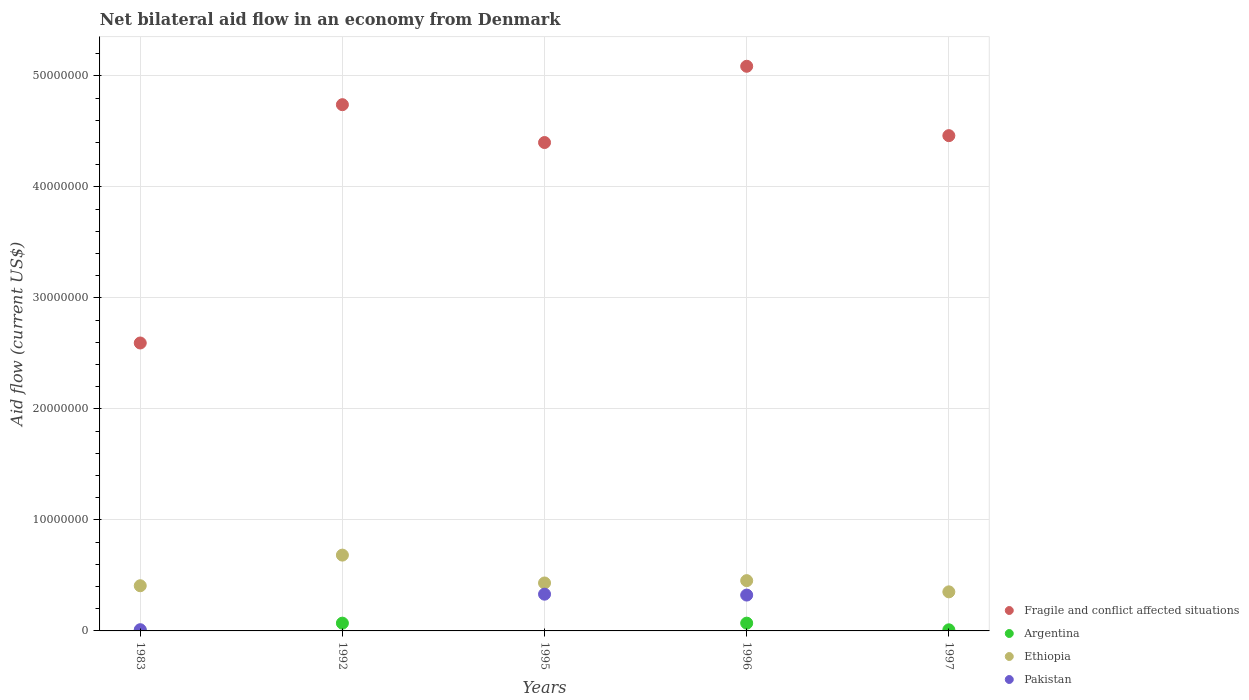How many different coloured dotlines are there?
Keep it short and to the point. 4. What is the net bilateral aid flow in Fragile and conflict affected situations in 1995?
Ensure brevity in your answer.  4.40e+07. Across all years, what is the maximum net bilateral aid flow in Ethiopia?
Ensure brevity in your answer.  6.83e+06. Across all years, what is the minimum net bilateral aid flow in Pakistan?
Your answer should be very brief. 0. What is the total net bilateral aid flow in Pakistan in the graph?
Offer a terse response. 6.65e+06. What is the difference between the net bilateral aid flow in Fragile and conflict affected situations in 1992 and the net bilateral aid flow in Pakistan in 1996?
Your answer should be compact. 4.42e+07. What is the average net bilateral aid flow in Fragile and conflict affected situations per year?
Make the answer very short. 4.26e+07. In the year 1996, what is the difference between the net bilateral aid flow in Fragile and conflict affected situations and net bilateral aid flow in Argentina?
Make the answer very short. 5.02e+07. What is the ratio of the net bilateral aid flow in Argentina in 1983 to that in 1996?
Offer a terse response. 0.01. What is the difference between the highest and the lowest net bilateral aid flow in Fragile and conflict affected situations?
Your answer should be compact. 2.49e+07. In how many years, is the net bilateral aid flow in Ethiopia greater than the average net bilateral aid flow in Ethiopia taken over all years?
Ensure brevity in your answer.  1. Is the sum of the net bilateral aid flow in Fragile and conflict affected situations in 1992 and 1995 greater than the maximum net bilateral aid flow in Argentina across all years?
Your answer should be compact. Yes. Is it the case that in every year, the sum of the net bilateral aid flow in Pakistan and net bilateral aid flow in Ethiopia  is greater than the sum of net bilateral aid flow in Argentina and net bilateral aid flow in Fragile and conflict affected situations?
Your response must be concise. Yes. Is it the case that in every year, the sum of the net bilateral aid flow in Fragile and conflict affected situations and net bilateral aid flow in Pakistan  is greater than the net bilateral aid flow in Ethiopia?
Make the answer very short. Yes. Does the net bilateral aid flow in Fragile and conflict affected situations monotonically increase over the years?
Your answer should be compact. No. Is the net bilateral aid flow in Ethiopia strictly less than the net bilateral aid flow in Fragile and conflict affected situations over the years?
Offer a terse response. Yes. How many dotlines are there?
Provide a succinct answer. 4. How many years are there in the graph?
Keep it short and to the point. 5. Are the values on the major ticks of Y-axis written in scientific E-notation?
Keep it short and to the point. No. Does the graph contain grids?
Your answer should be very brief. Yes. Where does the legend appear in the graph?
Provide a succinct answer. Bottom right. What is the title of the graph?
Give a very brief answer. Net bilateral aid flow in an economy from Denmark. What is the label or title of the Y-axis?
Your response must be concise. Aid flow (current US$). What is the Aid flow (current US$) of Fragile and conflict affected situations in 1983?
Give a very brief answer. 2.59e+07. What is the Aid flow (current US$) in Argentina in 1983?
Offer a terse response. 10000. What is the Aid flow (current US$) in Ethiopia in 1983?
Provide a succinct answer. 4.07e+06. What is the Aid flow (current US$) of Pakistan in 1983?
Give a very brief answer. 1.10e+05. What is the Aid flow (current US$) in Fragile and conflict affected situations in 1992?
Ensure brevity in your answer.  4.74e+07. What is the Aid flow (current US$) in Ethiopia in 1992?
Your answer should be compact. 6.83e+06. What is the Aid flow (current US$) in Fragile and conflict affected situations in 1995?
Your response must be concise. 4.40e+07. What is the Aid flow (current US$) in Argentina in 1995?
Provide a short and direct response. 0. What is the Aid flow (current US$) in Ethiopia in 1995?
Give a very brief answer. 4.32e+06. What is the Aid flow (current US$) in Pakistan in 1995?
Your response must be concise. 3.31e+06. What is the Aid flow (current US$) of Fragile and conflict affected situations in 1996?
Give a very brief answer. 5.09e+07. What is the Aid flow (current US$) in Ethiopia in 1996?
Ensure brevity in your answer.  4.53e+06. What is the Aid flow (current US$) of Pakistan in 1996?
Offer a terse response. 3.23e+06. What is the Aid flow (current US$) in Fragile and conflict affected situations in 1997?
Your answer should be compact. 4.46e+07. What is the Aid flow (current US$) in Ethiopia in 1997?
Give a very brief answer. 3.52e+06. Across all years, what is the maximum Aid flow (current US$) of Fragile and conflict affected situations?
Your answer should be very brief. 5.09e+07. Across all years, what is the maximum Aid flow (current US$) in Ethiopia?
Provide a short and direct response. 6.83e+06. Across all years, what is the maximum Aid flow (current US$) in Pakistan?
Your answer should be very brief. 3.31e+06. Across all years, what is the minimum Aid flow (current US$) in Fragile and conflict affected situations?
Make the answer very short. 2.59e+07. Across all years, what is the minimum Aid flow (current US$) of Ethiopia?
Keep it short and to the point. 3.52e+06. What is the total Aid flow (current US$) in Fragile and conflict affected situations in the graph?
Keep it short and to the point. 2.13e+08. What is the total Aid flow (current US$) in Argentina in the graph?
Keep it short and to the point. 1.51e+06. What is the total Aid flow (current US$) in Ethiopia in the graph?
Provide a short and direct response. 2.33e+07. What is the total Aid flow (current US$) of Pakistan in the graph?
Your response must be concise. 6.65e+06. What is the difference between the Aid flow (current US$) in Fragile and conflict affected situations in 1983 and that in 1992?
Make the answer very short. -2.15e+07. What is the difference between the Aid flow (current US$) in Argentina in 1983 and that in 1992?
Keep it short and to the point. -6.90e+05. What is the difference between the Aid flow (current US$) of Ethiopia in 1983 and that in 1992?
Your response must be concise. -2.76e+06. What is the difference between the Aid flow (current US$) in Fragile and conflict affected situations in 1983 and that in 1995?
Provide a short and direct response. -1.81e+07. What is the difference between the Aid flow (current US$) in Ethiopia in 1983 and that in 1995?
Provide a short and direct response. -2.50e+05. What is the difference between the Aid flow (current US$) of Pakistan in 1983 and that in 1995?
Give a very brief answer. -3.20e+06. What is the difference between the Aid flow (current US$) of Fragile and conflict affected situations in 1983 and that in 1996?
Offer a very short reply. -2.49e+07. What is the difference between the Aid flow (current US$) of Argentina in 1983 and that in 1996?
Make the answer very short. -6.90e+05. What is the difference between the Aid flow (current US$) of Ethiopia in 1983 and that in 1996?
Your answer should be very brief. -4.60e+05. What is the difference between the Aid flow (current US$) of Pakistan in 1983 and that in 1996?
Your response must be concise. -3.12e+06. What is the difference between the Aid flow (current US$) of Fragile and conflict affected situations in 1983 and that in 1997?
Your answer should be very brief. -1.87e+07. What is the difference between the Aid flow (current US$) of Argentina in 1983 and that in 1997?
Make the answer very short. -9.00e+04. What is the difference between the Aid flow (current US$) of Ethiopia in 1983 and that in 1997?
Make the answer very short. 5.50e+05. What is the difference between the Aid flow (current US$) of Fragile and conflict affected situations in 1992 and that in 1995?
Your response must be concise. 3.41e+06. What is the difference between the Aid flow (current US$) of Ethiopia in 1992 and that in 1995?
Your answer should be very brief. 2.51e+06. What is the difference between the Aid flow (current US$) of Fragile and conflict affected situations in 1992 and that in 1996?
Keep it short and to the point. -3.46e+06. What is the difference between the Aid flow (current US$) in Ethiopia in 1992 and that in 1996?
Keep it short and to the point. 2.30e+06. What is the difference between the Aid flow (current US$) of Fragile and conflict affected situations in 1992 and that in 1997?
Provide a short and direct response. 2.79e+06. What is the difference between the Aid flow (current US$) in Argentina in 1992 and that in 1997?
Provide a short and direct response. 6.00e+05. What is the difference between the Aid flow (current US$) in Ethiopia in 1992 and that in 1997?
Make the answer very short. 3.31e+06. What is the difference between the Aid flow (current US$) in Fragile and conflict affected situations in 1995 and that in 1996?
Offer a terse response. -6.87e+06. What is the difference between the Aid flow (current US$) in Pakistan in 1995 and that in 1996?
Your response must be concise. 8.00e+04. What is the difference between the Aid flow (current US$) in Fragile and conflict affected situations in 1995 and that in 1997?
Ensure brevity in your answer.  -6.20e+05. What is the difference between the Aid flow (current US$) in Fragile and conflict affected situations in 1996 and that in 1997?
Keep it short and to the point. 6.25e+06. What is the difference between the Aid flow (current US$) in Argentina in 1996 and that in 1997?
Your response must be concise. 6.00e+05. What is the difference between the Aid flow (current US$) of Ethiopia in 1996 and that in 1997?
Ensure brevity in your answer.  1.01e+06. What is the difference between the Aid flow (current US$) of Fragile and conflict affected situations in 1983 and the Aid flow (current US$) of Argentina in 1992?
Offer a very short reply. 2.52e+07. What is the difference between the Aid flow (current US$) in Fragile and conflict affected situations in 1983 and the Aid flow (current US$) in Ethiopia in 1992?
Keep it short and to the point. 1.91e+07. What is the difference between the Aid flow (current US$) in Argentina in 1983 and the Aid flow (current US$) in Ethiopia in 1992?
Your response must be concise. -6.82e+06. What is the difference between the Aid flow (current US$) in Fragile and conflict affected situations in 1983 and the Aid flow (current US$) in Ethiopia in 1995?
Ensure brevity in your answer.  2.16e+07. What is the difference between the Aid flow (current US$) of Fragile and conflict affected situations in 1983 and the Aid flow (current US$) of Pakistan in 1995?
Your answer should be compact. 2.26e+07. What is the difference between the Aid flow (current US$) in Argentina in 1983 and the Aid flow (current US$) in Ethiopia in 1995?
Your answer should be very brief. -4.31e+06. What is the difference between the Aid flow (current US$) in Argentina in 1983 and the Aid flow (current US$) in Pakistan in 1995?
Provide a short and direct response. -3.30e+06. What is the difference between the Aid flow (current US$) in Ethiopia in 1983 and the Aid flow (current US$) in Pakistan in 1995?
Provide a succinct answer. 7.60e+05. What is the difference between the Aid flow (current US$) in Fragile and conflict affected situations in 1983 and the Aid flow (current US$) in Argentina in 1996?
Offer a very short reply. 2.52e+07. What is the difference between the Aid flow (current US$) in Fragile and conflict affected situations in 1983 and the Aid flow (current US$) in Ethiopia in 1996?
Your response must be concise. 2.14e+07. What is the difference between the Aid flow (current US$) of Fragile and conflict affected situations in 1983 and the Aid flow (current US$) of Pakistan in 1996?
Provide a short and direct response. 2.27e+07. What is the difference between the Aid flow (current US$) in Argentina in 1983 and the Aid flow (current US$) in Ethiopia in 1996?
Keep it short and to the point. -4.52e+06. What is the difference between the Aid flow (current US$) of Argentina in 1983 and the Aid flow (current US$) of Pakistan in 1996?
Give a very brief answer. -3.22e+06. What is the difference between the Aid flow (current US$) in Ethiopia in 1983 and the Aid flow (current US$) in Pakistan in 1996?
Provide a succinct answer. 8.40e+05. What is the difference between the Aid flow (current US$) of Fragile and conflict affected situations in 1983 and the Aid flow (current US$) of Argentina in 1997?
Keep it short and to the point. 2.58e+07. What is the difference between the Aid flow (current US$) in Fragile and conflict affected situations in 1983 and the Aid flow (current US$) in Ethiopia in 1997?
Provide a short and direct response. 2.24e+07. What is the difference between the Aid flow (current US$) of Argentina in 1983 and the Aid flow (current US$) of Ethiopia in 1997?
Ensure brevity in your answer.  -3.51e+06. What is the difference between the Aid flow (current US$) of Fragile and conflict affected situations in 1992 and the Aid flow (current US$) of Ethiopia in 1995?
Offer a terse response. 4.31e+07. What is the difference between the Aid flow (current US$) in Fragile and conflict affected situations in 1992 and the Aid flow (current US$) in Pakistan in 1995?
Keep it short and to the point. 4.41e+07. What is the difference between the Aid flow (current US$) of Argentina in 1992 and the Aid flow (current US$) of Ethiopia in 1995?
Your answer should be very brief. -3.62e+06. What is the difference between the Aid flow (current US$) of Argentina in 1992 and the Aid flow (current US$) of Pakistan in 1995?
Keep it short and to the point. -2.61e+06. What is the difference between the Aid flow (current US$) in Ethiopia in 1992 and the Aid flow (current US$) in Pakistan in 1995?
Your answer should be very brief. 3.52e+06. What is the difference between the Aid flow (current US$) in Fragile and conflict affected situations in 1992 and the Aid flow (current US$) in Argentina in 1996?
Offer a very short reply. 4.67e+07. What is the difference between the Aid flow (current US$) in Fragile and conflict affected situations in 1992 and the Aid flow (current US$) in Ethiopia in 1996?
Provide a succinct answer. 4.29e+07. What is the difference between the Aid flow (current US$) in Fragile and conflict affected situations in 1992 and the Aid flow (current US$) in Pakistan in 1996?
Ensure brevity in your answer.  4.42e+07. What is the difference between the Aid flow (current US$) of Argentina in 1992 and the Aid flow (current US$) of Ethiopia in 1996?
Your answer should be compact. -3.83e+06. What is the difference between the Aid flow (current US$) in Argentina in 1992 and the Aid flow (current US$) in Pakistan in 1996?
Make the answer very short. -2.53e+06. What is the difference between the Aid flow (current US$) in Ethiopia in 1992 and the Aid flow (current US$) in Pakistan in 1996?
Ensure brevity in your answer.  3.60e+06. What is the difference between the Aid flow (current US$) in Fragile and conflict affected situations in 1992 and the Aid flow (current US$) in Argentina in 1997?
Ensure brevity in your answer.  4.73e+07. What is the difference between the Aid flow (current US$) of Fragile and conflict affected situations in 1992 and the Aid flow (current US$) of Ethiopia in 1997?
Give a very brief answer. 4.39e+07. What is the difference between the Aid flow (current US$) in Argentina in 1992 and the Aid flow (current US$) in Ethiopia in 1997?
Your response must be concise. -2.82e+06. What is the difference between the Aid flow (current US$) in Fragile and conflict affected situations in 1995 and the Aid flow (current US$) in Argentina in 1996?
Your answer should be compact. 4.33e+07. What is the difference between the Aid flow (current US$) in Fragile and conflict affected situations in 1995 and the Aid flow (current US$) in Ethiopia in 1996?
Offer a terse response. 3.95e+07. What is the difference between the Aid flow (current US$) of Fragile and conflict affected situations in 1995 and the Aid flow (current US$) of Pakistan in 1996?
Keep it short and to the point. 4.08e+07. What is the difference between the Aid flow (current US$) in Ethiopia in 1995 and the Aid flow (current US$) in Pakistan in 1996?
Your answer should be very brief. 1.09e+06. What is the difference between the Aid flow (current US$) in Fragile and conflict affected situations in 1995 and the Aid flow (current US$) in Argentina in 1997?
Make the answer very short. 4.39e+07. What is the difference between the Aid flow (current US$) of Fragile and conflict affected situations in 1995 and the Aid flow (current US$) of Ethiopia in 1997?
Your answer should be compact. 4.05e+07. What is the difference between the Aid flow (current US$) in Fragile and conflict affected situations in 1996 and the Aid flow (current US$) in Argentina in 1997?
Make the answer very short. 5.08e+07. What is the difference between the Aid flow (current US$) in Fragile and conflict affected situations in 1996 and the Aid flow (current US$) in Ethiopia in 1997?
Your answer should be compact. 4.74e+07. What is the difference between the Aid flow (current US$) of Argentina in 1996 and the Aid flow (current US$) of Ethiopia in 1997?
Offer a terse response. -2.82e+06. What is the average Aid flow (current US$) in Fragile and conflict affected situations per year?
Ensure brevity in your answer.  4.26e+07. What is the average Aid flow (current US$) in Argentina per year?
Ensure brevity in your answer.  3.02e+05. What is the average Aid flow (current US$) in Ethiopia per year?
Make the answer very short. 4.65e+06. What is the average Aid flow (current US$) in Pakistan per year?
Keep it short and to the point. 1.33e+06. In the year 1983, what is the difference between the Aid flow (current US$) in Fragile and conflict affected situations and Aid flow (current US$) in Argentina?
Keep it short and to the point. 2.59e+07. In the year 1983, what is the difference between the Aid flow (current US$) of Fragile and conflict affected situations and Aid flow (current US$) of Ethiopia?
Provide a succinct answer. 2.19e+07. In the year 1983, what is the difference between the Aid flow (current US$) of Fragile and conflict affected situations and Aid flow (current US$) of Pakistan?
Offer a terse response. 2.58e+07. In the year 1983, what is the difference between the Aid flow (current US$) in Argentina and Aid flow (current US$) in Ethiopia?
Offer a very short reply. -4.06e+06. In the year 1983, what is the difference between the Aid flow (current US$) of Argentina and Aid flow (current US$) of Pakistan?
Your answer should be compact. -1.00e+05. In the year 1983, what is the difference between the Aid flow (current US$) in Ethiopia and Aid flow (current US$) in Pakistan?
Keep it short and to the point. 3.96e+06. In the year 1992, what is the difference between the Aid flow (current US$) in Fragile and conflict affected situations and Aid flow (current US$) in Argentina?
Provide a succinct answer. 4.67e+07. In the year 1992, what is the difference between the Aid flow (current US$) of Fragile and conflict affected situations and Aid flow (current US$) of Ethiopia?
Your answer should be compact. 4.06e+07. In the year 1992, what is the difference between the Aid flow (current US$) of Argentina and Aid flow (current US$) of Ethiopia?
Your response must be concise. -6.13e+06. In the year 1995, what is the difference between the Aid flow (current US$) in Fragile and conflict affected situations and Aid flow (current US$) in Ethiopia?
Ensure brevity in your answer.  3.97e+07. In the year 1995, what is the difference between the Aid flow (current US$) in Fragile and conflict affected situations and Aid flow (current US$) in Pakistan?
Your answer should be compact. 4.07e+07. In the year 1995, what is the difference between the Aid flow (current US$) of Ethiopia and Aid flow (current US$) of Pakistan?
Keep it short and to the point. 1.01e+06. In the year 1996, what is the difference between the Aid flow (current US$) of Fragile and conflict affected situations and Aid flow (current US$) of Argentina?
Give a very brief answer. 5.02e+07. In the year 1996, what is the difference between the Aid flow (current US$) of Fragile and conflict affected situations and Aid flow (current US$) of Ethiopia?
Keep it short and to the point. 4.63e+07. In the year 1996, what is the difference between the Aid flow (current US$) in Fragile and conflict affected situations and Aid flow (current US$) in Pakistan?
Your response must be concise. 4.76e+07. In the year 1996, what is the difference between the Aid flow (current US$) in Argentina and Aid flow (current US$) in Ethiopia?
Keep it short and to the point. -3.83e+06. In the year 1996, what is the difference between the Aid flow (current US$) in Argentina and Aid flow (current US$) in Pakistan?
Your answer should be very brief. -2.53e+06. In the year 1996, what is the difference between the Aid flow (current US$) in Ethiopia and Aid flow (current US$) in Pakistan?
Ensure brevity in your answer.  1.30e+06. In the year 1997, what is the difference between the Aid flow (current US$) of Fragile and conflict affected situations and Aid flow (current US$) of Argentina?
Your answer should be very brief. 4.45e+07. In the year 1997, what is the difference between the Aid flow (current US$) in Fragile and conflict affected situations and Aid flow (current US$) in Ethiopia?
Your answer should be compact. 4.11e+07. In the year 1997, what is the difference between the Aid flow (current US$) in Argentina and Aid flow (current US$) in Ethiopia?
Provide a short and direct response. -3.42e+06. What is the ratio of the Aid flow (current US$) in Fragile and conflict affected situations in 1983 to that in 1992?
Make the answer very short. 0.55. What is the ratio of the Aid flow (current US$) of Argentina in 1983 to that in 1992?
Give a very brief answer. 0.01. What is the ratio of the Aid flow (current US$) of Ethiopia in 1983 to that in 1992?
Ensure brevity in your answer.  0.6. What is the ratio of the Aid flow (current US$) in Fragile and conflict affected situations in 1983 to that in 1995?
Offer a very short reply. 0.59. What is the ratio of the Aid flow (current US$) in Ethiopia in 1983 to that in 1995?
Provide a short and direct response. 0.94. What is the ratio of the Aid flow (current US$) in Pakistan in 1983 to that in 1995?
Offer a terse response. 0.03. What is the ratio of the Aid flow (current US$) of Fragile and conflict affected situations in 1983 to that in 1996?
Give a very brief answer. 0.51. What is the ratio of the Aid flow (current US$) of Argentina in 1983 to that in 1996?
Your response must be concise. 0.01. What is the ratio of the Aid flow (current US$) in Ethiopia in 1983 to that in 1996?
Make the answer very short. 0.9. What is the ratio of the Aid flow (current US$) in Pakistan in 1983 to that in 1996?
Your answer should be compact. 0.03. What is the ratio of the Aid flow (current US$) in Fragile and conflict affected situations in 1983 to that in 1997?
Your response must be concise. 0.58. What is the ratio of the Aid flow (current US$) of Argentina in 1983 to that in 1997?
Give a very brief answer. 0.1. What is the ratio of the Aid flow (current US$) of Ethiopia in 1983 to that in 1997?
Keep it short and to the point. 1.16. What is the ratio of the Aid flow (current US$) in Fragile and conflict affected situations in 1992 to that in 1995?
Ensure brevity in your answer.  1.08. What is the ratio of the Aid flow (current US$) of Ethiopia in 1992 to that in 1995?
Keep it short and to the point. 1.58. What is the ratio of the Aid flow (current US$) of Fragile and conflict affected situations in 1992 to that in 1996?
Your response must be concise. 0.93. What is the ratio of the Aid flow (current US$) of Ethiopia in 1992 to that in 1996?
Make the answer very short. 1.51. What is the ratio of the Aid flow (current US$) in Fragile and conflict affected situations in 1992 to that in 1997?
Provide a short and direct response. 1.06. What is the ratio of the Aid flow (current US$) of Ethiopia in 1992 to that in 1997?
Offer a terse response. 1.94. What is the ratio of the Aid flow (current US$) of Fragile and conflict affected situations in 1995 to that in 1996?
Ensure brevity in your answer.  0.86. What is the ratio of the Aid flow (current US$) in Ethiopia in 1995 to that in 1996?
Your response must be concise. 0.95. What is the ratio of the Aid flow (current US$) in Pakistan in 1995 to that in 1996?
Your answer should be compact. 1.02. What is the ratio of the Aid flow (current US$) of Fragile and conflict affected situations in 1995 to that in 1997?
Give a very brief answer. 0.99. What is the ratio of the Aid flow (current US$) in Ethiopia in 1995 to that in 1997?
Your response must be concise. 1.23. What is the ratio of the Aid flow (current US$) in Fragile and conflict affected situations in 1996 to that in 1997?
Ensure brevity in your answer.  1.14. What is the ratio of the Aid flow (current US$) of Ethiopia in 1996 to that in 1997?
Offer a very short reply. 1.29. What is the difference between the highest and the second highest Aid flow (current US$) in Fragile and conflict affected situations?
Your answer should be very brief. 3.46e+06. What is the difference between the highest and the second highest Aid flow (current US$) in Ethiopia?
Make the answer very short. 2.30e+06. What is the difference between the highest and the second highest Aid flow (current US$) in Pakistan?
Provide a succinct answer. 8.00e+04. What is the difference between the highest and the lowest Aid flow (current US$) in Fragile and conflict affected situations?
Provide a succinct answer. 2.49e+07. What is the difference between the highest and the lowest Aid flow (current US$) in Argentina?
Keep it short and to the point. 7.00e+05. What is the difference between the highest and the lowest Aid flow (current US$) of Ethiopia?
Offer a very short reply. 3.31e+06. What is the difference between the highest and the lowest Aid flow (current US$) in Pakistan?
Your answer should be compact. 3.31e+06. 